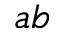<formula> <loc_0><loc_0><loc_500><loc_500>a b</formula> 